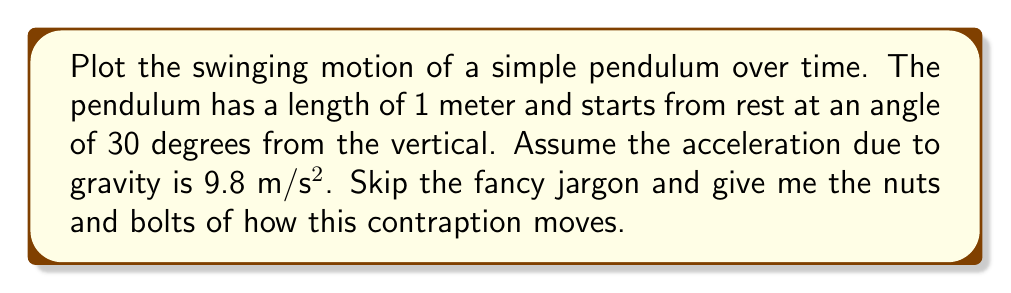Teach me how to tackle this problem. Alright, let's break this down without any fluff:

1. First, we need to understand what drives the pendulum's motion. It's gravity, plain and simple.

2. The pendulum swings back and forth in a circular arc. We can describe this motion using two key variables:
   - $\theta$: the angle from the vertical (in radians)
   - $t$: time (in seconds)

3. For small angles, the motion of a pendulum is approximately simple harmonic. The angle $\theta$ at any time $t$ is given by:

   $$\theta(t) = \theta_0 \cos(\omega t)$$

   Where:
   - $\theta_0$ is the initial angle (30° or $\pi/6$ radians)
   - $\omega$ is the angular frequency, given by $\sqrt{g/L}$
   - $g$ is the acceleration due to gravity (9.8 m/s²)
   - $L$ is the length of the pendulum (1 m)

4. Let's calculate $\omega$:
   $$\omega = \sqrt{9.8/1} = \sqrt{9.8} \approx 3.13 \text{ rad/s}$$

5. Now, we can write the equation for $\theta(t)$:
   $$\theta(t) = \frac{\pi}{6} \cos(3.13t)$$

6. To plot the motion, we need the x and y coordinates of the bob (the weight at the end of the pendulum). These are given by:

   $$x(t) = L \sin(\theta(t)) = \sin(\frac{\pi}{6} \cos(3.13t))$$
   $$y(t) = -L \cos(\theta(t)) = -\cos(\frac{\pi}{6} \cos(3.13t))$$

7. These equations give us the position of the pendulum bob at any time $t$. To plot the motion, we'd calculate x and y for various values of $t$ and connect the dots.
Answer: The parametric equations describing the motion of the pendulum bob are:

$$x(t) = \sin(\frac{\pi}{6} \cos(3.13t))$$
$$y(t) = -\cos(\frac{\pi}{6} \cos(3.13t))$$

where $t$ is time in seconds, and $x$ and $y$ are in meters. 